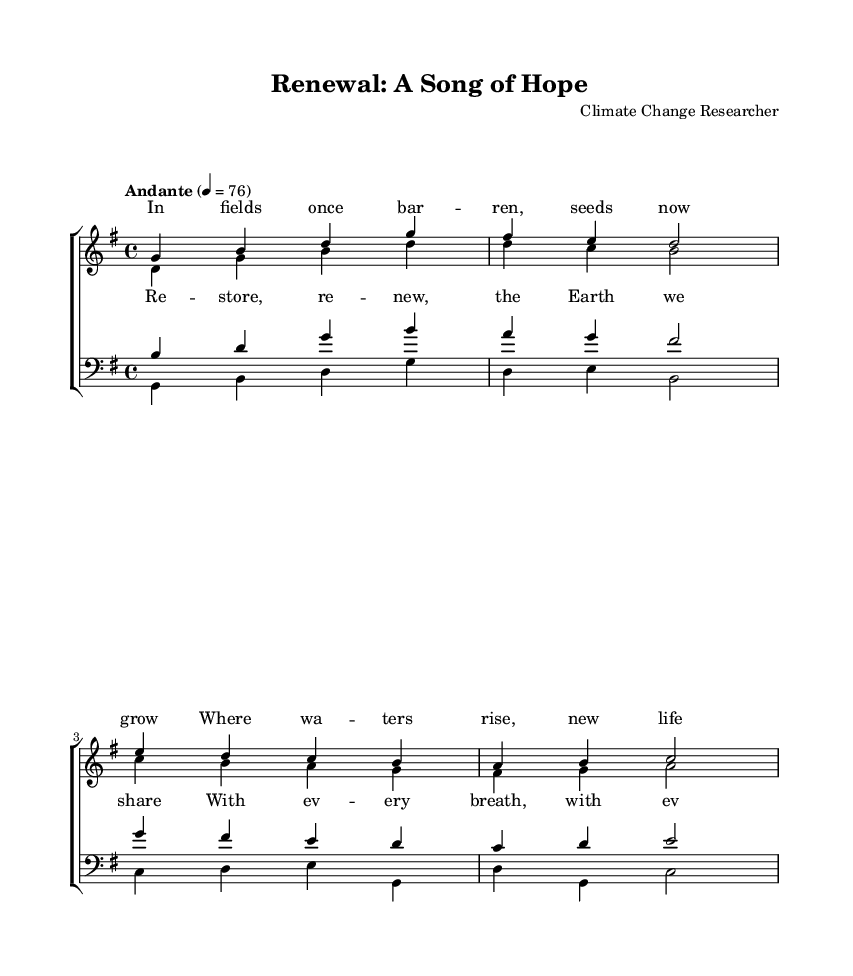What is the key signature of this music? The key signature indicates the key of G major, which includes one sharp (F#). The key signature is located at the beginning of the staff, showing which notes are altered.
Answer: G major What is the time signature of this music? The time signature is shown at the beginning of the score and indicates the number of beats in each measure, which is 4 beats per measure in this case.
Answer: 4/4 What is the tempo marking for this piece? The tempo marking is indicated at the beginning, stating the speed of the music. It specifies "Andante," which translates to a moderately slow pace, approximately 76 beats per minute.
Answer: Andante How many voices are in the choral arrangement? The choir consists of four distinct voices; soprano, alto, tenor, and bass. This can be determined by the number of individual staff lines designated for each vocal part.
Answer: Four What phrase is repeated in the chorus? The repeated phrase in the chorus is about restoration of the Earth, and it emphasizes action with words "Restore, renew." This is determined from analyzing the lyrics under the staff for the chorus section.
Answer: Restore, renew Which voice has the highest pitch range? The soprano voice typically has the highest pitch range in the choral arrangement. By observing the notation, the notes notated for sopranos are consistently higher than those for other voices.
Answer: Soprano What lyrical theme is evident throughout the music? The lyrics convey optimism and hope for environmental restoration, expressed through phrases about growth and renewal. This can be derived from the lyrics provided in both the verse and chorus sections.
Answer: Hope for restoration 